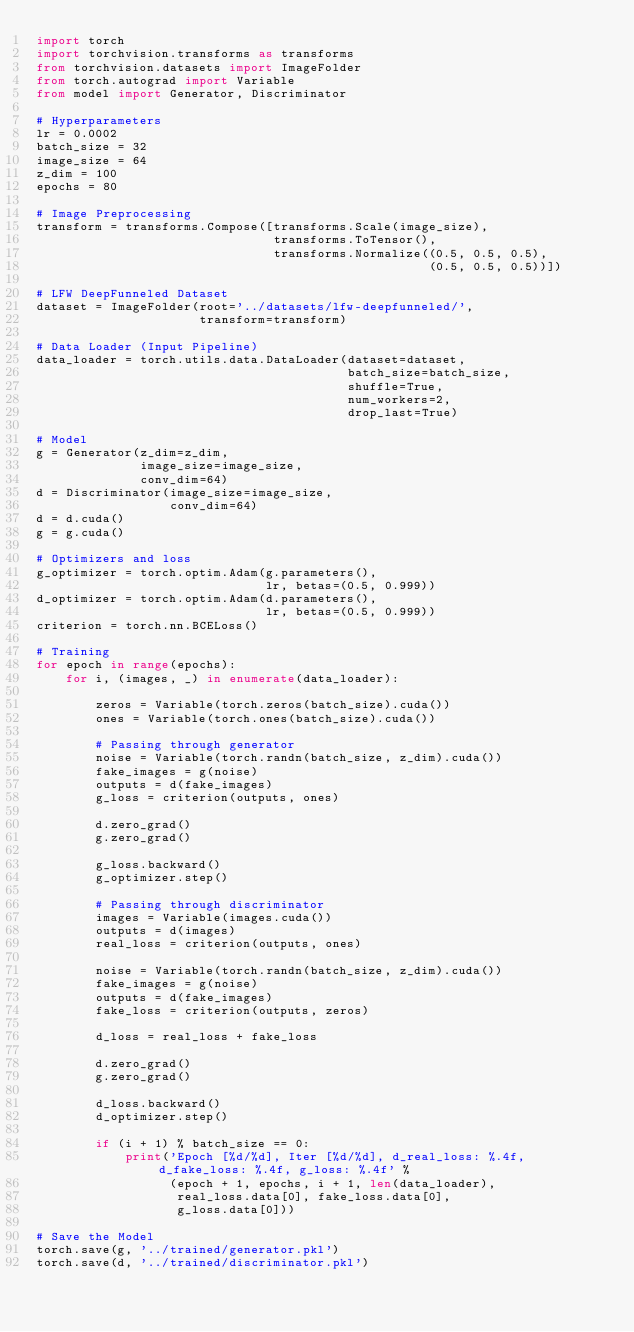Convert code to text. <code><loc_0><loc_0><loc_500><loc_500><_Python_>import torch
import torchvision.transforms as transforms
from torchvision.datasets import ImageFolder
from torch.autograd import Variable
from model import Generator, Discriminator

# Hyperparameters
lr = 0.0002
batch_size = 32
image_size = 64
z_dim = 100
epochs = 80

# Image Preprocessing
transform = transforms.Compose([transforms.Scale(image_size),
                                transforms.ToTensor(),
                                transforms.Normalize((0.5, 0.5, 0.5),
                                                     (0.5, 0.5, 0.5))])

# LFW DeepFunneled Dataset
dataset = ImageFolder(root='../datasets/lfw-deepfunneled/',
                      transform=transform)

# Data Loader (Input Pipeline)
data_loader = torch.utils.data.DataLoader(dataset=dataset,
                                          batch_size=batch_size,
                                          shuffle=True,
                                          num_workers=2,
                                          drop_last=True)

# Model
g = Generator(z_dim=z_dim,
              image_size=image_size,
              conv_dim=64)
d = Discriminator(image_size=image_size,
                  conv_dim=64)
d = d.cuda()
g = g.cuda()

# Optimizers and loss
g_optimizer = torch.optim.Adam(g.parameters(),
                               lr, betas=(0.5, 0.999))
d_optimizer = torch.optim.Adam(d.parameters(),
                               lr, betas=(0.5, 0.999))
criterion = torch.nn.BCELoss()

# Training
for epoch in range(epochs):
    for i, (images, _) in enumerate(data_loader):

        zeros = Variable(torch.zeros(batch_size).cuda())
        ones = Variable(torch.ones(batch_size).cuda())

        # Passing through generator
        noise = Variable(torch.randn(batch_size, z_dim).cuda())
        fake_images = g(noise)
        outputs = d(fake_images)
        g_loss = criterion(outputs, ones)

        d.zero_grad()
        g.zero_grad()

        g_loss.backward()
        g_optimizer.step()

        # Passing through discriminator
        images = Variable(images.cuda())
        outputs = d(images)
        real_loss = criterion(outputs, ones)

        noise = Variable(torch.randn(batch_size, z_dim).cuda())
        fake_images = g(noise)
        outputs = d(fake_images)
        fake_loss = criterion(outputs, zeros)

        d_loss = real_loss + fake_loss

        d.zero_grad()
        g.zero_grad()

        d_loss.backward()
        d_optimizer.step()

        if (i + 1) % batch_size == 0:
            print('Epoch [%d/%d], Iter [%d/%d], d_real_loss: %.4f, d_fake_loss: %.4f, g_loss: %.4f' %
                  (epoch + 1, epochs, i + 1, len(data_loader),
                   real_loss.data[0], fake_loss.data[0],
                   g_loss.data[0]))

# Save the Model
torch.save(g, '../trained/generator.pkl')
torch.save(d, '../trained/discriminator.pkl')
</code> 